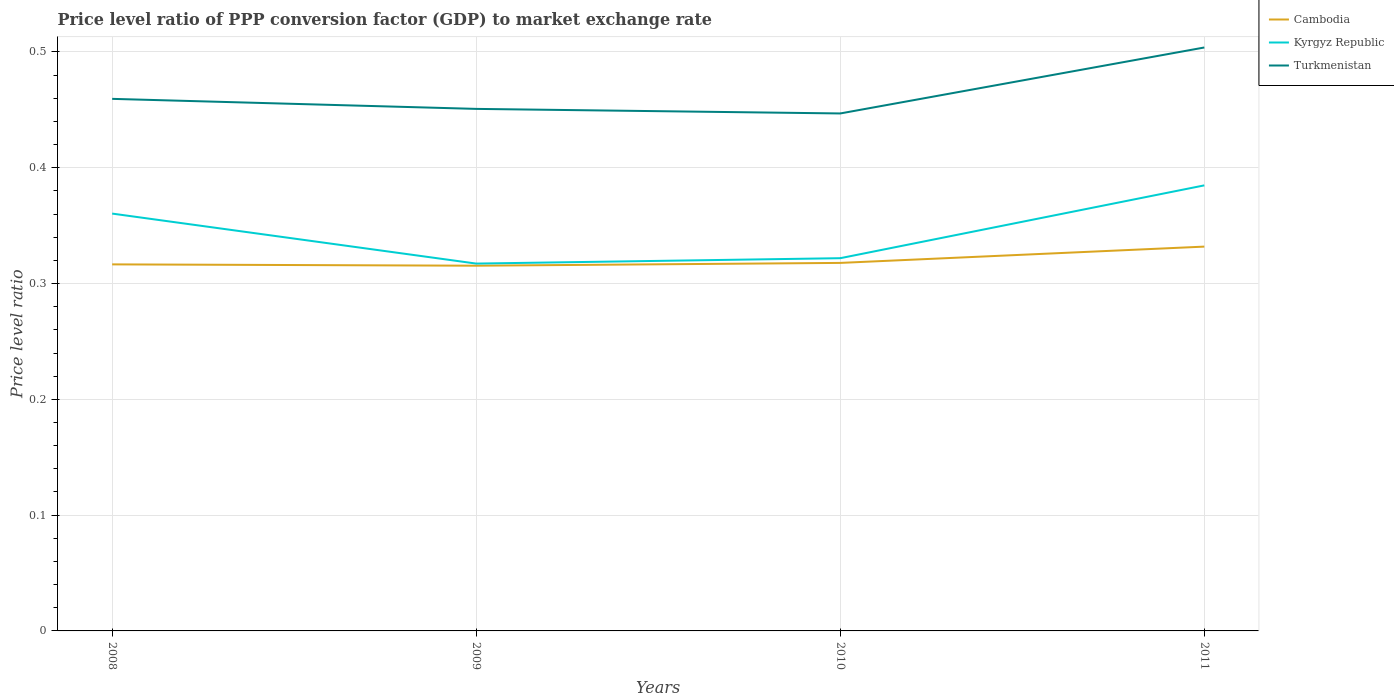How many different coloured lines are there?
Ensure brevity in your answer.  3. Is the number of lines equal to the number of legend labels?
Provide a succinct answer. Yes. Across all years, what is the maximum price level ratio in Turkmenistan?
Ensure brevity in your answer.  0.45. In which year was the price level ratio in Turkmenistan maximum?
Your answer should be compact. 2010. What is the total price level ratio in Cambodia in the graph?
Provide a succinct answer. -0.02. What is the difference between the highest and the second highest price level ratio in Turkmenistan?
Keep it short and to the point. 0.06. Is the price level ratio in Cambodia strictly greater than the price level ratio in Kyrgyz Republic over the years?
Your response must be concise. Yes. How many lines are there?
Keep it short and to the point. 3. How many years are there in the graph?
Ensure brevity in your answer.  4. What is the difference between two consecutive major ticks on the Y-axis?
Provide a succinct answer. 0.1. Are the values on the major ticks of Y-axis written in scientific E-notation?
Provide a short and direct response. No. Does the graph contain any zero values?
Your answer should be compact. No. Does the graph contain grids?
Offer a terse response. Yes. How many legend labels are there?
Give a very brief answer. 3. What is the title of the graph?
Your answer should be very brief. Price level ratio of PPP conversion factor (GDP) to market exchange rate. Does "European Union" appear as one of the legend labels in the graph?
Your answer should be compact. No. What is the label or title of the Y-axis?
Offer a very short reply. Price level ratio. What is the Price level ratio of Cambodia in 2008?
Offer a terse response. 0.32. What is the Price level ratio in Kyrgyz Republic in 2008?
Keep it short and to the point. 0.36. What is the Price level ratio in Turkmenistan in 2008?
Offer a terse response. 0.46. What is the Price level ratio in Cambodia in 2009?
Your answer should be compact. 0.32. What is the Price level ratio of Kyrgyz Republic in 2009?
Offer a terse response. 0.32. What is the Price level ratio in Turkmenistan in 2009?
Offer a terse response. 0.45. What is the Price level ratio in Cambodia in 2010?
Offer a terse response. 0.32. What is the Price level ratio of Kyrgyz Republic in 2010?
Give a very brief answer. 0.32. What is the Price level ratio in Turkmenistan in 2010?
Provide a succinct answer. 0.45. What is the Price level ratio in Cambodia in 2011?
Keep it short and to the point. 0.33. What is the Price level ratio in Kyrgyz Republic in 2011?
Give a very brief answer. 0.38. What is the Price level ratio in Turkmenistan in 2011?
Make the answer very short. 0.5. Across all years, what is the maximum Price level ratio of Cambodia?
Your answer should be very brief. 0.33. Across all years, what is the maximum Price level ratio of Kyrgyz Republic?
Keep it short and to the point. 0.38. Across all years, what is the maximum Price level ratio in Turkmenistan?
Your response must be concise. 0.5. Across all years, what is the minimum Price level ratio of Cambodia?
Give a very brief answer. 0.32. Across all years, what is the minimum Price level ratio in Kyrgyz Republic?
Give a very brief answer. 0.32. Across all years, what is the minimum Price level ratio in Turkmenistan?
Provide a succinct answer. 0.45. What is the total Price level ratio in Cambodia in the graph?
Ensure brevity in your answer.  1.28. What is the total Price level ratio of Kyrgyz Republic in the graph?
Make the answer very short. 1.38. What is the total Price level ratio in Turkmenistan in the graph?
Your answer should be very brief. 1.86. What is the difference between the Price level ratio of Cambodia in 2008 and that in 2009?
Ensure brevity in your answer.  0. What is the difference between the Price level ratio of Kyrgyz Republic in 2008 and that in 2009?
Provide a short and direct response. 0.04. What is the difference between the Price level ratio of Turkmenistan in 2008 and that in 2009?
Keep it short and to the point. 0.01. What is the difference between the Price level ratio in Cambodia in 2008 and that in 2010?
Make the answer very short. -0. What is the difference between the Price level ratio of Kyrgyz Republic in 2008 and that in 2010?
Offer a very short reply. 0.04. What is the difference between the Price level ratio of Turkmenistan in 2008 and that in 2010?
Give a very brief answer. 0.01. What is the difference between the Price level ratio of Cambodia in 2008 and that in 2011?
Your response must be concise. -0.02. What is the difference between the Price level ratio in Kyrgyz Republic in 2008 and that in 2011?
Your answer should be compact. -0.02. What is the difference between the Price level ratio in Turkmenistan in 2008 and that in 2011?
Ensure brevity in your answer.  -0.04. What is the difference between the Price level ratio in Cambodia in 2009 and that in 2010?
Give a very brief answer. -0. What is the difference between the Price level ratio of Kyrgyz Republic in 2009 and that in 2010?
Offer a very short reply. -0. What is the difference between the Price level ratio of Turkmenistan in 2009 and that in 2010?
Your response must be concise. 0. What is the difference between the Price level ratio in Cambodia in 2009 and that in 2011?
Provide a succinct answer. -0.02. What is the difference between the Price level ratio of Kyrgyz Republic in 2009 and that in 2011?
Give a very brief answer. -0.07. What is the difference between the Price level ratio in Turkmenistan in 2009 and that in 2011?
Provide a succinct answer. -0.05. What is the difference between the Price level ratio in Cambodia in 2010 and that in 2011?
Your answer should be very brief. -0.01. What is the difference between the Price level ratio in Kyrgyz Republic in 2010 and that in 2011?
Offer a very short reply. -0.06. What is the difference between the Price level ratio in Turkmenistan in 2010 and that in 2011?
Ensure brevity in your answer.  -0.06. What is the difference between the Price level ratio of Cambodia in 2008 and the Price level ratio of Kyrgyz Republic in 2009?
Offer a terse response. -0. What is the difference between the Price level ratio in Cambodia in 2008 and the Price level ratio in Turkmenistan in 2009?
Give a very brief answer. -0.13. What is the difference between the Price level ratio in Kyrgyz Republic in 2008 and the Price level ratio in Turkmenistan in 2009?
Your response must be concise. -0.09. What is the difference between the Price level ratio of Cambodia in 2008 and the Price level ratio of Kyrgyz Republic in 2010?
Your response must be concise. -0.01. What is the difference between the Price level ratio of Cambodia in 2008 and the Price level ratio of Turkmenistan in 2010?
Keep it short and to the point. -0.13. What is the difference between the Price level ratio of Kyrgyz Republic in 2008 and the Price level ratio of Turkmenistan in 2010?
Your answer should be very brief. -0.09. What is the difference between the Price level ratio of Cambodia in 2008 and the Price level ratio of Kyrgyz Republic in 2011?
Give a very brief answer. -0.07. What is the difference between the Price level ratio of Cambodia in 2008 and the Price level ratio of Turkmenistan in 2011?
Provide a succinct answer. -0.19. What is the difference between the Price level ratio in Kyrgyz Republic in 2008 and the Price level ratio in Turkmenistan in 2011?
Ensure brevity in your answer.  -0.14. What is the difference between the Price level ratio of Cambodia in 2009 and the Price level ratio of Kyrgyz Republic in 2010?
Provide a succinct answer. -0.01. What is the difference between the Price level ratio in Cambodia in 2009 and the Price level ratio in Turkmenistan in 2010?
Your answer should be compact. -0.13. What is the difference between the Price level ratio of Kyrgyz Republic in 2009 and the Price level ratio of Turkmenistan in 2010?
Your answer should be very brief. -0.13. What is the difference between the Price level ratio of Cambodia in 2009 and the Price level ratio of Kyrgyz Republic in 2011?
Your response must be concise. -0.07. What is the difference between the Price level ratio of Cambodia in 2009 and the Price level ratio of Turkmenistan in 2011?
Offer a very short reply. -0.19. What is the difference between the Price level ratio in Kyrgyz Republic in 2009 and the Price level ratio in Turkmenistan in 2011?
Provide a short and direct response. -0.19. What is the difference between the Price level ratio of Cambodia in 2010 and the Price level ratio of Kyrgyz Republic in 2011?
Ensure brevity in your answer.  -0.07. What is the difference between the Price level ratio in Cambodia in 2010 and the Price level ratio in Turkmenistan in 2011?
Ensure brevity in your answer.  -0.19. What is the difference between the Price level ratio of Kyrgyz Republic in 2010 and the Price level ratio of Turkmenistan in 2011?
Your answer should be very brief. -0.18. What is the average Price level ratio in Cambodia per year?
Offer a terse response. 0.32. What is the average Price level ratio of Kyrgyz Republic per year?
Your response must be concise. 0.35. What is the average Price level ratio in Turkmenistan per year?
Your response must be concise. 0.47. In the year 2008, what is the difference between the Price level ratio of Cambodia and Price level ratio of Kyrgyz Republic?
Your answer should be compact. -0.04. In the year 2008, what is the difference between the Price level ratio in Cambodia and Price level ratio in Turkmenistan?
Offer a very short reply. -0.14. In the year 2008, what is the difference between the Price level ratio of Kyrgyz Republic and Price level ratio of Turkmenistan?
Provide a short and direct response. -0.1. In the year 2009, what is the difference between the Price level ratio in Cambodia and Price level ratio in Kyrgyz Republic?
Provide a short and direct response. -0. In the year 2009, what is the difference between the Price level ratio of Cambodia and Price level ratio of Turkmenistan?
Provide a succinct answer. -0.14. In the year 2009, what is the difference between the Price level ratio in Kyrgyz Republic and Price level ratio in Turkmenistan?
Ensure brevity in your answer.  -0.13. In the year 2010, what is the difference between the Price level ratio of Cambodia and Price level ratio of Kyrgyz Republic?
Your answer should be compact. -0. In the year 2010, what is the difference between the Price level ratio in Cambodia and Price level ratio in Turkmenistan?
Provide a succinct answer. -0.13. In the year 2010, what is the difference between the Price level ratio of Kyrgyz Republic and Price level ratio of Turkmenistan?
Ensure brevity in your answer.  -0.12. In the year 2011, what is the difference between the Price level ratio in Cambodia and Price level ratio in Kyrgyz Republic?
Your answer should be very brief. -0.05. In the year 2011, what is the difference between the Price level ratio of Cambodia and Price level ratio of Turkmenistan?
Your answer should be very brief. -0.17. In the year 2011, what is the difference between the Price level ratio in Kyrgyz Republic and Price level ratio in Turkmenistan?
Your response must be concise. -0.12. What is the ratio of the Price level ratio in Kyrgyz Republic in 2008 to that in 2009?
Your response must be concise. 1.14. What is the ratio of the Price level ratio in Turkmenistan in 2008 to that in 2009?
Offer a terse response. 1.02. What is the ratio of the Price level ratio of Kyrgyz Republic in 2008 to that in 2010?
Your answer should be very brief. 1.12. What is the ratio of the Price level ratio of Turkmenistan in 2008 to that in 2010?
Offer a terse response. 1.03. What is the ratio of the Price level ratio of Cambodia in 2008 to that in 2011?
Offer a very short reply. 0.95. What is the ratio of the Price level ratio of Kyrgyz Republic in 2008 to that in 2011?
Your response must be concise. 0.94. What is the ratio of the Price level ratio in Turkmenistan in 2008 to that in 2011?
Give a very brief answer. 0.91. What is the ratio of the Price level ratio of Cambodia in 2009 to that in 2010?
Keep it short and to the point. 0.99. What is the ratio of the Price level ratio in Kyrgyz Republic in 2009 to that in 2010?
Keep it short and to the point. 0.99. What is the ratio of the Price level ratio of Turkmenistan in 2009 to that in 2010?
Ensure brevity in your answer.  1.01. What is the ratio of the Price level ratio in Cambodia in 2009 to that in 2011?
Your answer should be very brief. 0.95. What is the ratio of the Price level ratio in Kyrgyz Republic in 2009 to that in 2011?
Give a very brief answer. 0.82. What is the ratio of the Price level ratio of Turkmenistan in 2009 to that in 2011?
Provide a short and direct response. 0.89. What is the ratio of the Price level ratio of Cambodia in 2010 to that in 2011?
Your answer should be very brief. 0.96. What is the ratio of the Price level ratio in Kyrgyz Republic in 2010 to that in 2011?
Give a very brief answer. 0.84. What is the ratio of the Price level ratio in Turkmenistan in 2010 to that in 2011?
Make the answer very short. 0.89. What is the difference between the highest and the second highest Price level ratio in Cambodia?
Make the answer very short. 0.01. What is the difference between the highest and the second highest Price level ratio in Kyrgyz Republic?
Keep it short and to the point. 0.02. What is the difference between the highest and the second highest Price level ratio in Turkmenistan?
Your answer should be compact. 0.04. What is the difference between the highest and the lowest Price level ratio in Cambodia?
Provide a short and direct response. 0.02. What is the difference between the highest and the lowest Price level ratio in Kyrgyz Republic?
Give a very brief answer. 0.07. What is the difference between the highest and the lowest Price level ratio in Turkmenistan?
Make the answer very short. 0.06. 